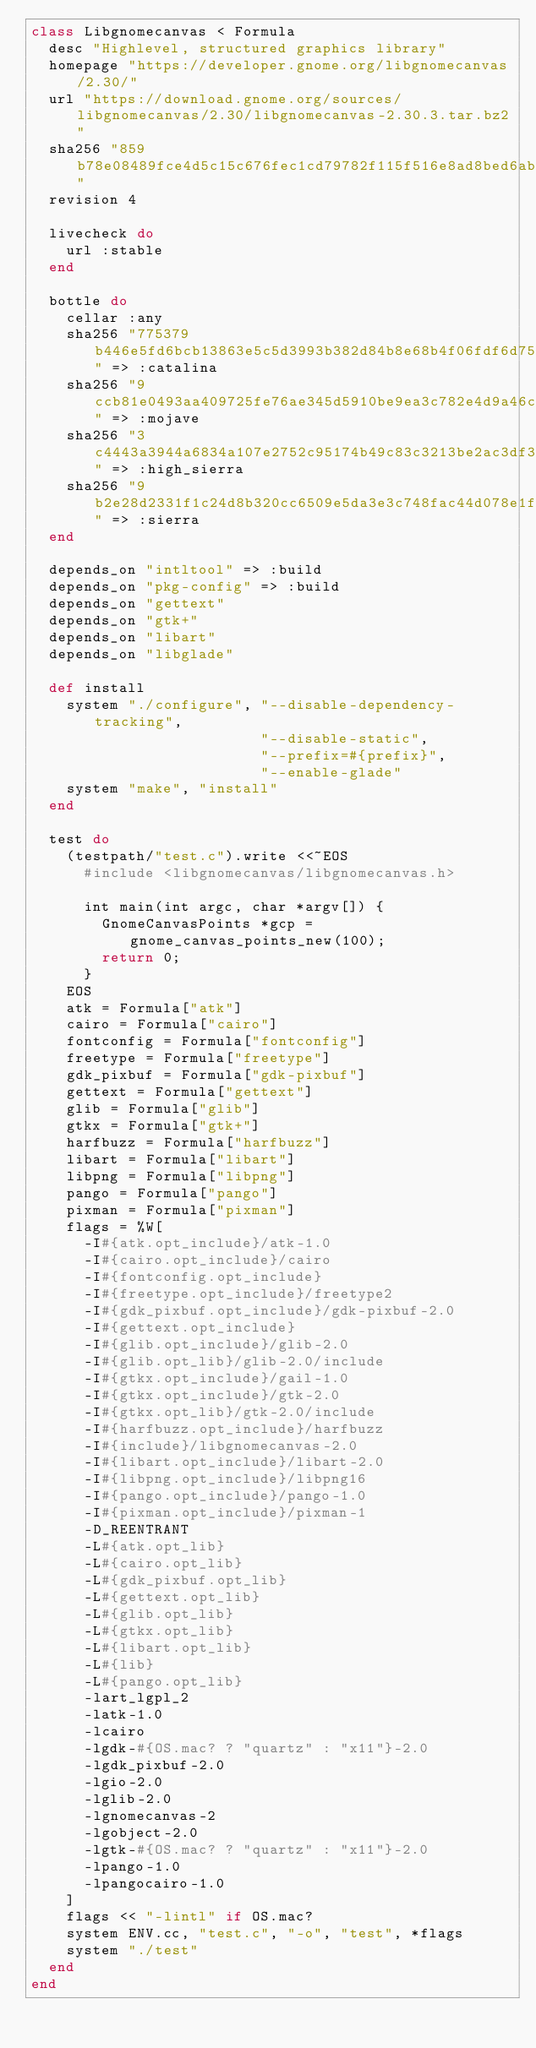Convert code to text. <code><loc_0><loc_0><loc_500><loc_500><_Ruby_>class Libgnomecanvas < Formula
  desc "Highlevel, structured graphics library"
  homepage "https://developer.gnome.org/libgnomecanvas/2.30/"
  url "https://download.gnome.org/sources/libgnomecanvas/2.30/libgnomecanvas-2.30.3.tar.bz2"
  sha256 "859b78e08489fce4d5c15c676fec1cd79782f115f516e8ad8bed6abcb8dedd40"
  revision 4

  livecheck do
    url :stable
  end

  bottle do
    cellar :any
    sha256 "775379b446e5fd6bcb13863e5c5d3993b382d84b8e68b4f06fdf6d758921cb81" => :catalina
    sha256 "9ccb81e0493aa409725fe76ae345d5910be9ea3c782e4d9a46c24c42b0537150" => :mojave
    sha256 "3c4443a3944a6834a107e2752c95174b49c83c3213be2ac3df319bfd900c22e6" => :high_sierra
    sha256 "9b2e28d2331f1c24d8b320cc6509e5da3e3c748fac44d078e1f95c6c701b7b10" => :sierra
  end

  depends_on "intltool" => :build
  depends_on "pkg-config" => :build
  depends_on "gettext"
  depends_on "gtk+"
  depends_on "libart"
  depends_on "libglade"

  def install
    system "./configure", "--disable-dependency-tracking",
                          "--disable-static",
                          "--prefix=#{prefix}",
                          "--enable-glade"
    system "make", "install"
  end

  test do
    (testpath/"test.c").write <<~EOS
      #include <libgnomecanvas/libgnomecanvas.h>

      int main(int argc, char *argv[]) {
        GnomeCanvasPoints *gcp = gnome_canvas_points_new(100);
        return 0;
      }
    EOS
    atk = Formula["atk"]
    cairo = Formula["cairo"]
    fontconfig = Formula["fontconfig"]
    freetype = Formula["freetype"]
    gdk_pixbuf = Formula["gdk-pixbuf"]
    gettext = Formula["gettext"]
    glib = Formula["glib"]
    gtkx = Formula["gtk+"]
    harfbuzz = Formula["harfbuzz"]
    libart = Formula["libart"]
    libpng = Formula["libpng"]
    pango = Formula["pango"]
    pixman = Formula["pixman"]
    flags = %W[
      -I#{atk.opt_include}/atk-1.0
      -I#{cairo.opt_include}/cairo
      -I#{fontconfig.opt_include}
      -I#{freetype.opt_include}/freetype2
      -I#{gdk_pixbuf.opt_include}/gdk-pixbuf-2.0
      -I#{gettext.opt_include}
      -I#{glib.opt_include}/glib-2.0
      -I#{glib.opt_lib}/glib-2.0/include
      -I#{gtkx.opt_include}/gail-1.0
      -I#{gtkx.opt_include}/gtk-2.0
      -I#{gtkx.opt_lib}/gtk-2.0/include
      -I#{harfbuzz.opt_include}/harfbuzz
      -I#{include}/libgnomecanvas-2.0
      -I#{libart.opt_include}/libart-2.0
      -I#{libpng.opt_include}/libpng16
      -I#{pango.opt_include}/pango-1.0
      -I#{pixman.opt_include}/pixman-1
      -D_REENTRANT
      -L#{atk.opt_lib}
      -L#{cairo.opt_lib}
      -L#{gdk_pixbuf.opt_lib}
      -L#{gettext.opt_lib}
      -L#{glib.opt_lib}
      -L#{gtkx.opt_lib}
      -L#{libart.opt_lib}
      -L#{lib}
      -L#{pango.opt_lib}
      -lart_lgpl_2
      -latk-1.0
      -lcairo
      -lgdk-#{OS.mac? ? "quartz" : "x11"}-2.0
      -lgdk_pixbuf-2.0
      -lgio-2.0
      -lglib-2.0
      -lgnomecanvas-2
      -lgobject-2.0
      -lgtk-#{OS.mac? ? "quartz" : "x11"}-2.0
      -lpango-1.0
      -lpangocairo-1.0
    ]
    flags << "-lintl" if OS.mac?
    system ENV.cc, "test.c", "-o", "test", *flags
    system "./test"
  end
end
</code> 